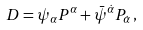<formula> <loc_0><loc_0><loc_500><loc_500>D = \psi _ { \alpha } P ^ { \alpha } + \bar { \psi } ^ { \dot { \alpha } } P _ { \dot { \alpha } } \, ,</formula> 